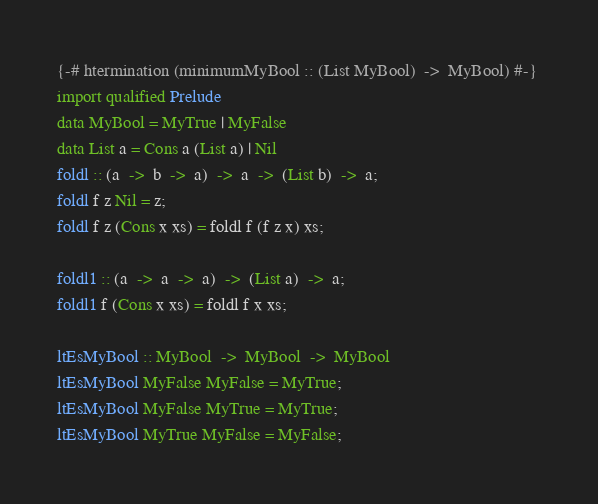<code> <loc_0><loc_0><loc_500><loc_500><_Haskell_>{-# htermination (minimumMyBool :: (List MyBool)  ->  MyBool) #-} 
import qualified Prelude 
data MyBool = MyTrue | MyFalse 
data List a = Cons a (List a) | Nil 
foldl :: (a  ->  b  ->  a)  ->  a  ->  (List b)  ->  a;
foldl f z Nil = z;
foldl f z (Cons x xs) = foldl f (f z x) xs;

foldl1 :: (a  ->  a  ->  a)  ->  (List a)  ->  a;
foldl1 f (Cons x xs) = foldl f x xs;

ltEsMyBool :: MyBool  ->  MyBool  ->  MyBool
ltEsMyBool MyFalse MyFalse = MyTrue;
ltEsMyBool MyFalse MyTrue = MyTrue;
ltEsMyBool MyTrue MyFalse = MyFalse;</code> 